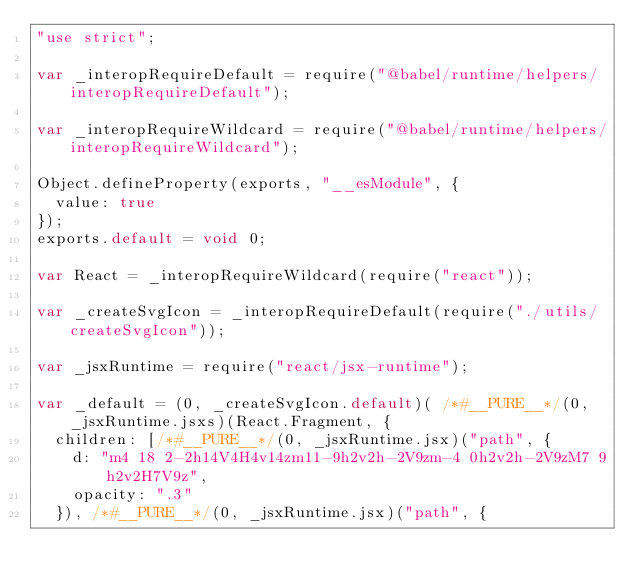<code> <loc_0><loc_0><loc_500><loc_500><_JavaScript_>"use strict";

var _interopRequireDefault = require("@babel/runtime/helpers/interopRequireDefault");

var _interopRequireWildcard = require("@babel/runtime/helpers/interopRequireWildcard");

Object.defineProperty(exports, "__esModule", {
  value: true
});
exports.default = void 0;

var React = _interopRequireWildcard(require("react"));

var _createSvgIcon = _interopRequireDefault(require("./utils/createSvgIcon"));

var _jsxRuntime = require("react/jsx-runtime");

var _default = (0, _createSvgIcon.default)( /*#__PURE__*/(0, _jsxRuntime.jsxs)(React.Fragment, {
  children: [/*#__PURE__*/(0, _jsxRuntime.jsx)("path", {
    d: "m4 18 2-2h14V4H4v14zm11-9h2v2h-2V9zm-4 0h2v2h-2V9zM7 9h2v2H7V9z",
    opacity: ".3"
  }), /*#__PURE__*/(0, _jsxRuntime.jsx)("path", {</code> 